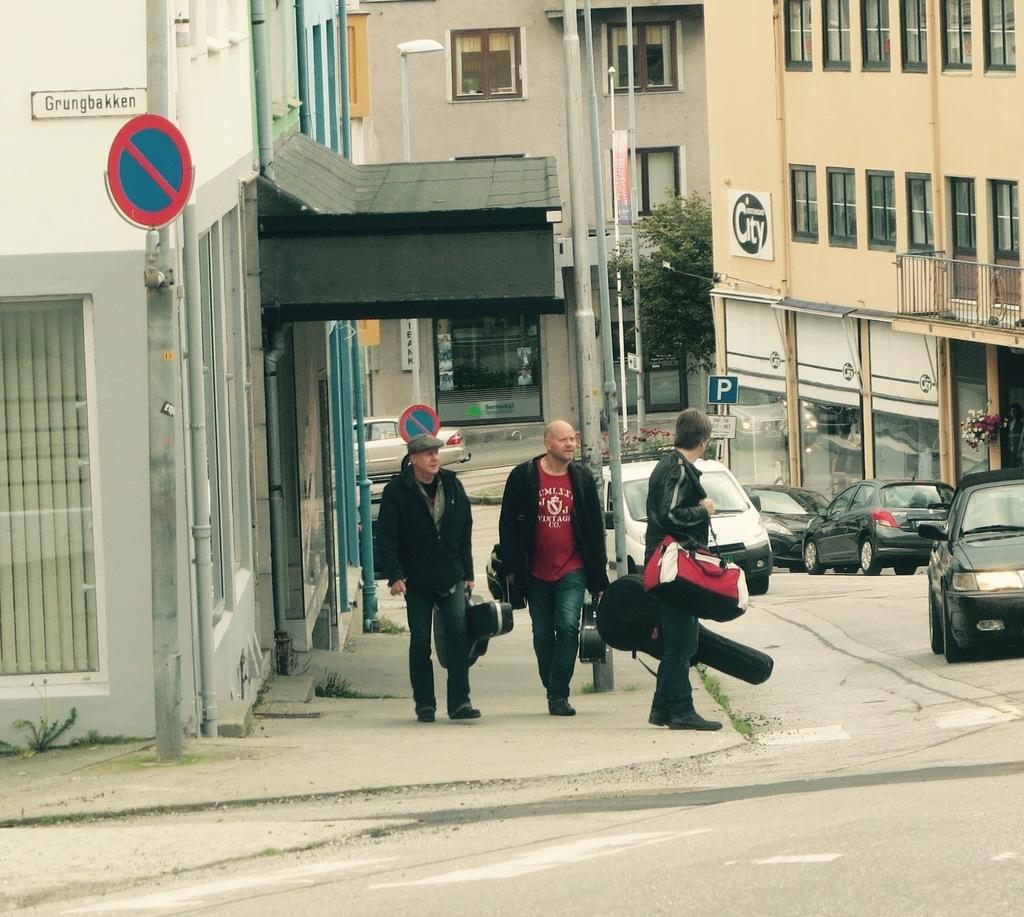<image>
Share a concise interpretation of the image provided. the outside of a building with a sign on it that says 'grungbakken' 